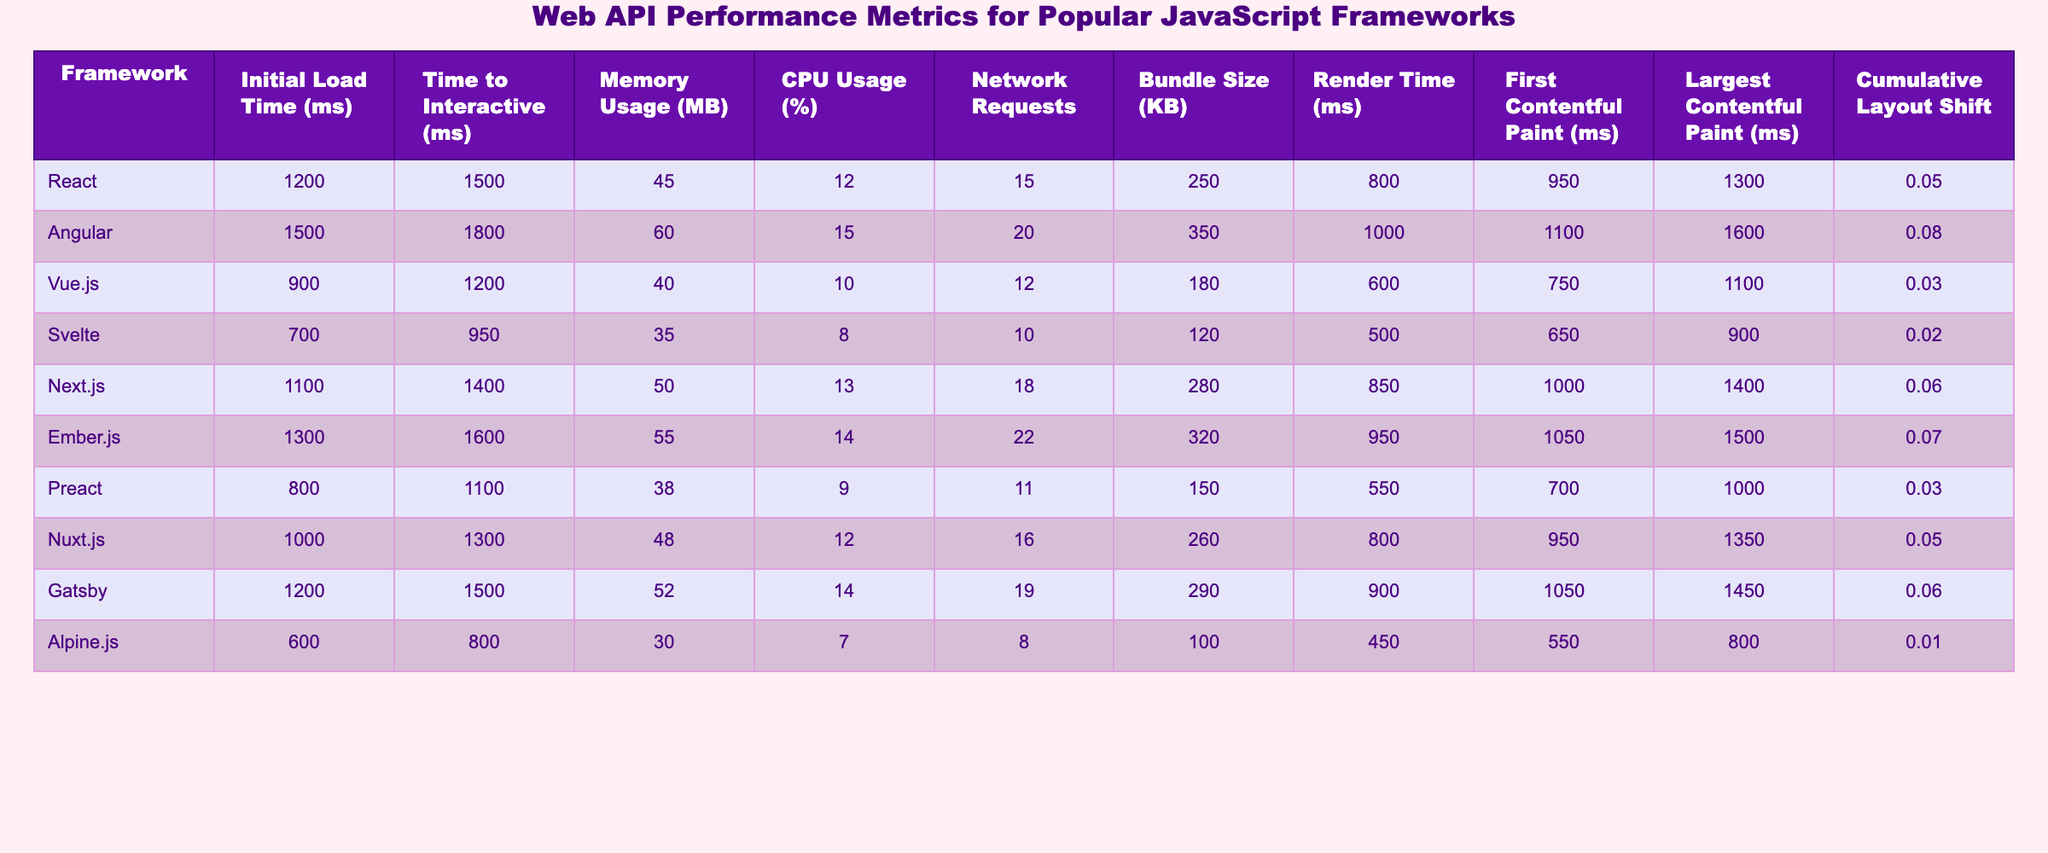What is the initial load time for Vue.js? The table shows that the initial load time for Vue.js is listed as 900 ms.
Answer: 900 ms Which framework has the highest CPU usage? By examining the CPU usage values, Angular has the highest CPU usage at 15%.
Answer: 15% What is the memory usage of Svelte? The table indicates that Svelte has a memory usage of 35 MB.
Answer: 35 MB Which framework has the lowest number of network requests? Looking at the network requests, Alpine.js has the lowest with 8 requests.
Answer: 8 What is the difference in initial load time between Angular and React? The initial load time for Angular is 1500 ms and React is 1200 ms. The difference is 1500 - 1200 = 300 ms.
Answer: 300 ms What is the average bundle size of all frameworks listed? The sum of all bundle sizes is (250 + 350 + 180 + 120 + 280 + 320 + 150 + 260 + 290 + 100) = 2200 KB. There are 10 frameworks, so the average is 2200/10 = 220 KB.
Answer: 220 KB Is the largest contentful paint for Preact less than that of Vue.js? The largest contentful paint for Preact is 1000 ms and for Vue.js it is 1100 ms. Since 1000 ms is less than 1100 ms, the answer is yes.
Answer: Yes Which framework has both the lowest initial load time and the lowest memory usage? The lowest initial load time is for Svelte at 700 ms, which also has the lowest memory usage of 35 MB. Thus, the answer is Svelte.
Answer: Svelte What is the percentage of Cumulative Layout Shift for Angular? The Cumulative Layout Shift for Angular is shown as 0.08 in the table.
Answer: 0.08 If we combine the render times of Svelte and Alpine.js, what will be the total? The render time for Svelte is 500 ms and for Alpine.js it is 450 ms. Their combined render time is 500 + 450 = 950 ms.
Answer: 950 ms 